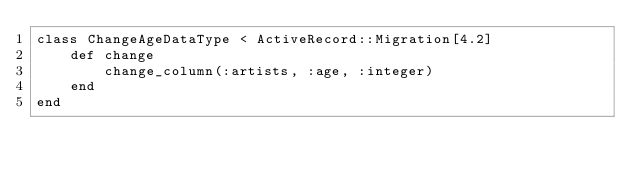Convert code to text. <code><loc_0><loc_0><loc_500><loc_500><_Ruby_>class ChangeAgeDataType < ActiveRecord::Migration[4.2]
    def change 
        change_column(:artists, :age, :integer)
    end
end</code> 